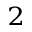<formula> <loc_0><loc_0><loc_500><loc_500>^ { 2 }</formula> 